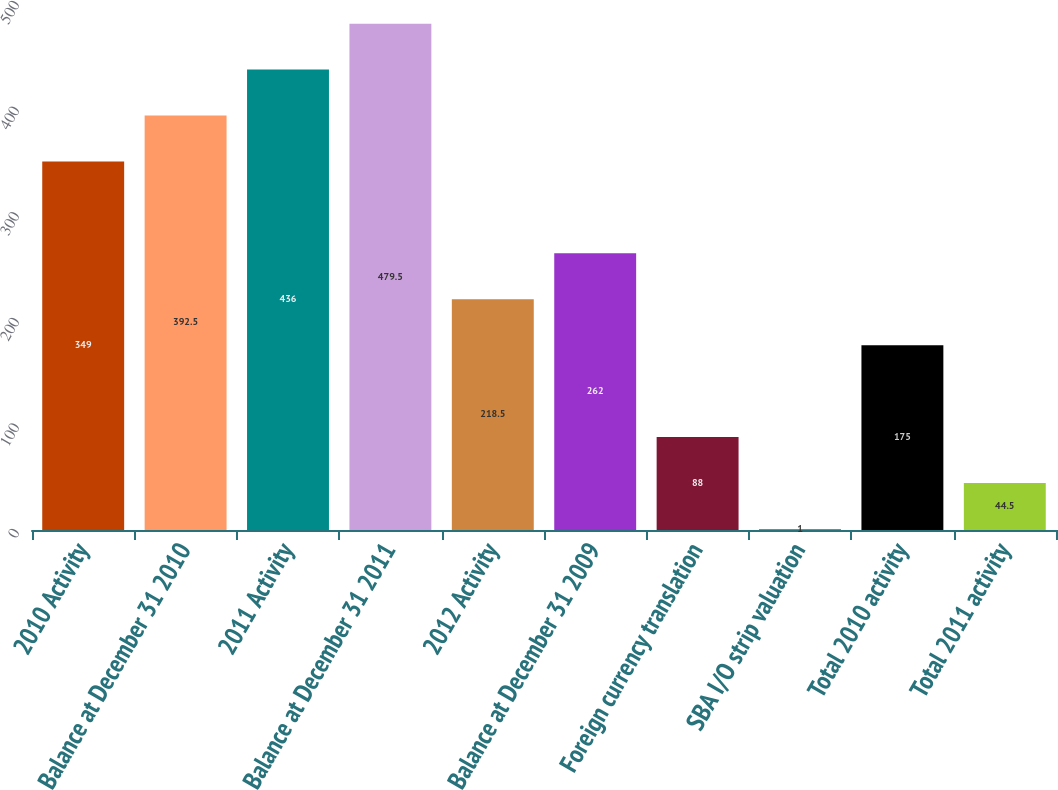Convert chart to OTSL. <chart><loc_0><loc_0><loc_500><loc_500><bar_chart><fcel>2010 Activity<fcel>Balance at December 31 2010<fcel>2011 Activity<fcel>Balance at December 31 2011<fcel>2012 Activity<fcel>Balance at December 31 2009<fcel>Foreign currency translation<fcel>SBA I/O strip valuation<fcel>Total 2010 activity<fcel>Total 2011 activity<nl><fcel>349<fcel>392.5<fcel>436<fcel>479.5<fcel>218.5<fcel>262<fcel>88<fcel>1<fcel>175<fcel>44.5<nl></chart> 